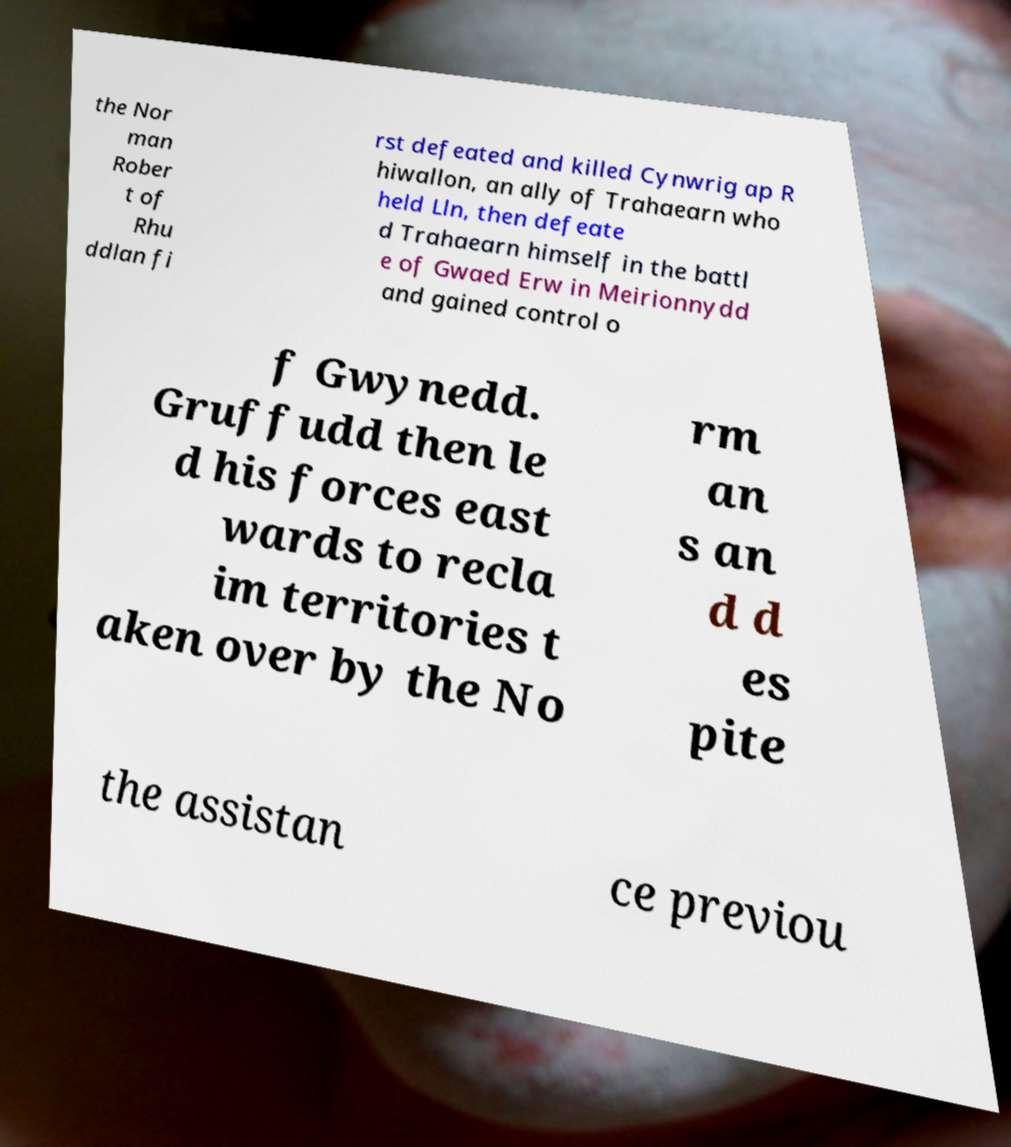Please identify and transcribe the text found in this image. the Nor man Rober t of Rhu ddlan fi rst defeated and killed Cynwrig ap R hiwallon, an ally of Trahaearn who held Lln, then defeate d Trahaearn himself in the battl e of Gwaed Erw in Meirionnydd and gained control o f Gwynedd. Gruffudd then le d his forces east wards to recla im territories t aken over by the No rm an s an d d es pite the assistan ce previou 